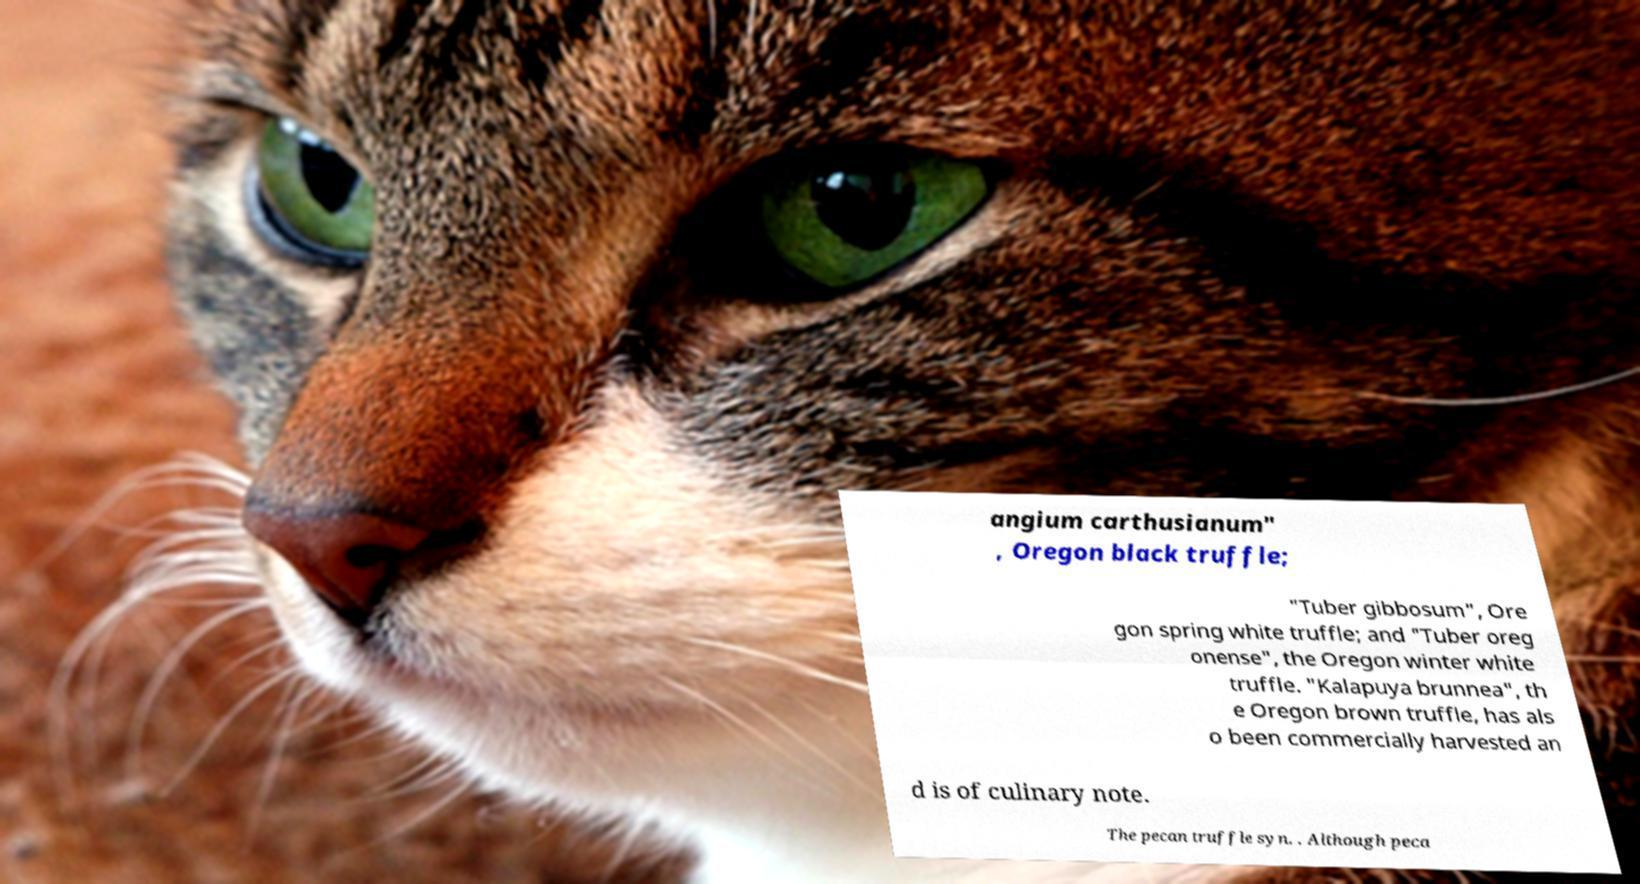Could you assist in decoding the text presented in this image and type it out clearly? angium carthusianum" , Oregon black truffle; "Tuber gibbosum", Ore gon spring white truffle; and "Tuber oreg onense", the Oregon winter white truffle. "Kalapuya brunnea", th e Oregon brown truffle, has als o been commercially harvested an d is of culinary note. The pecan truffle syn. . Although peca 